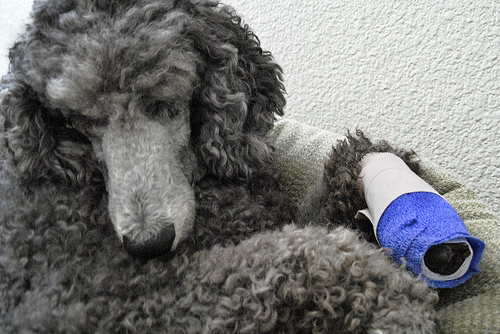<image>
Is the bandage on the floor? No. The bandage is not positioned on the floor. They may be near each other, but the bandage is not supported by or resting on top of the floor. 